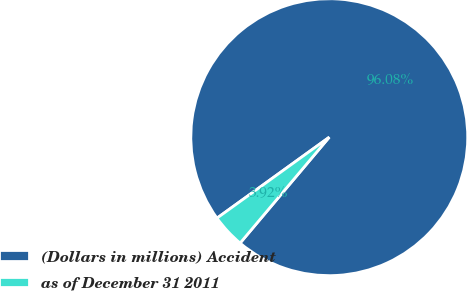Convert chart. <chart><loc_0><loc_0><loc_500><loc_500><pie_chart><fcel>(Dollars in millions) Accident<fcel>as of December 31 2011<nl><fcel>96.08%<fcel>3.92%<nl></chart> 